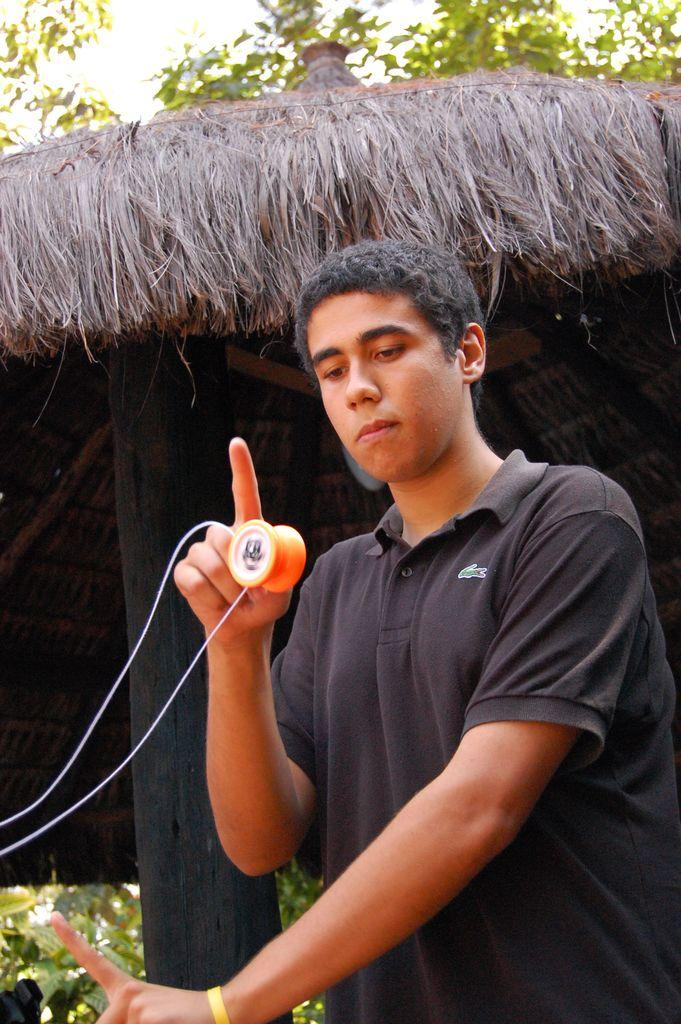What is the main subject of the image? There is a man in the image. What is the man doing in the image? The man is standing in the image. What is the man holding in his hand? The man is holding a top in his hand. What can be seen in the background of the image? There are trees, sky, and a thatched shed visible in the background of the image. What type of food is the man eating in the image? There is no food present in the image; the man is holding a top in his hand. What color is the man's skin in the image? The provided facts do not mention the man's skin color, so it cannot be determined from the image. 